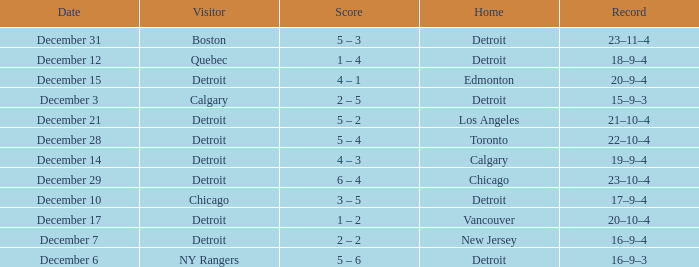What is the score on december 10? 3 – 5. 